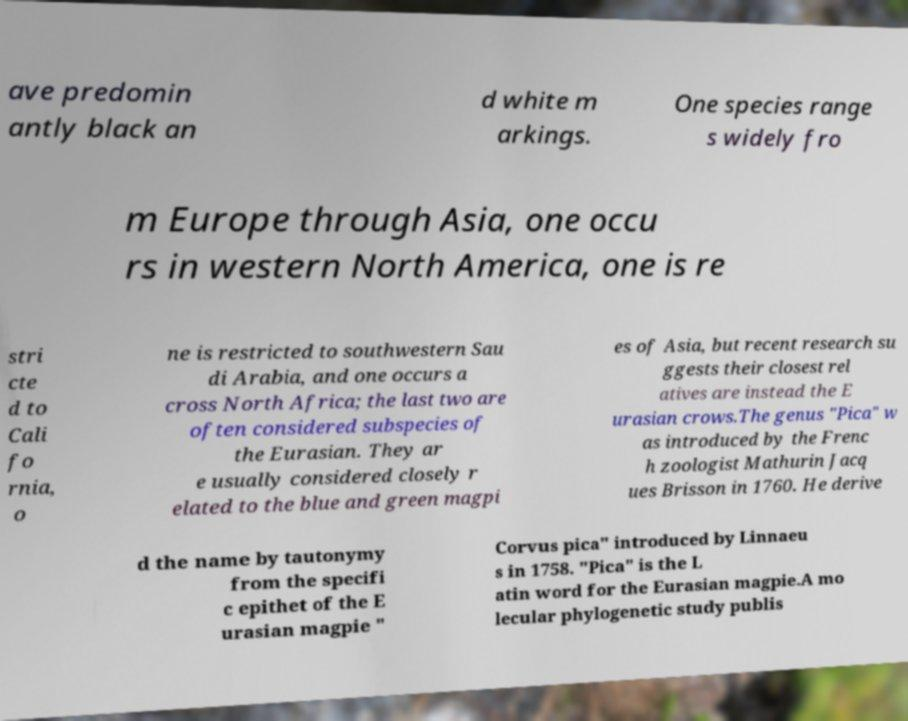Could you assist in decoding the text presented in this image and type it out clearly? ave predomin antly black an d white m arkings. One species range s widely fro m Europe through Asia, one occu rs in western North America, one is re stri cte d to Cali fo rnia, o ne is restricted to southwestern Sau di Arabia, and one occurs a cross North Africa; the last two are often considered subspecies of the Eurasian. They ar e usually considered closely r elated to the blue and green magpi es of Asia, but recent research su ggests their closest rel atives are instead the E urasian crows.The genus "Pica" w as introduced by the Frenc h zoologist Mathurin Jacq ues Brisson in 1760. He derive d the name by tautonymy from the specifi c epithet of the E urasian magpie " Corvus pica" introduced by Linnaeu s in 1758. "Pica" is the L atin word for the Eurasian magpie.A mo lecular phylogenetic study publis 